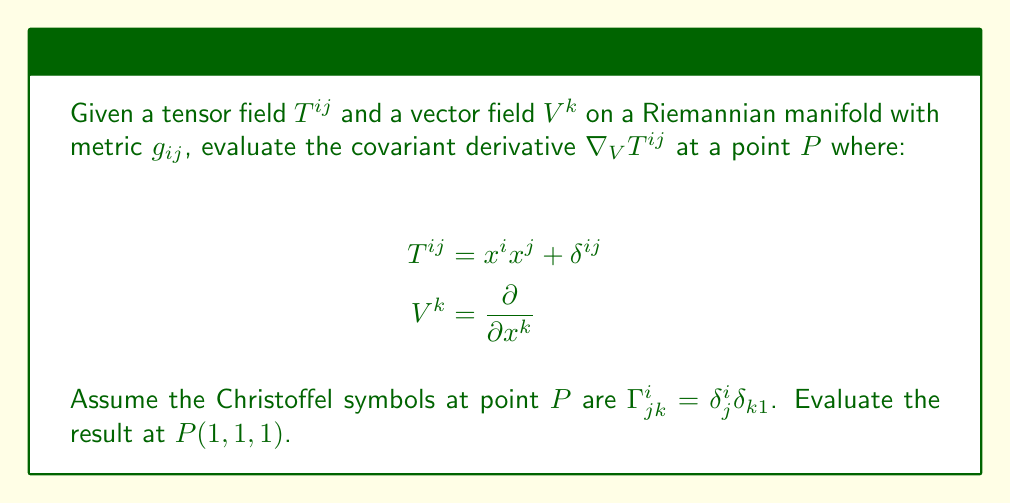Can you solve this math problem? To evaluate the covariant derivative of $T^{ij}$ along $V^k$, we use the formula:

$$\nabla_V T^{ij} = V^k \nabla_k T^{ij} = V^k (\partial_k T^{ij} + \Gamma^i_{kl} T^{lj} + \Gamma^j_{kl} T^{il})$$

Step 1: Calculate $\partial_k T^{ij}$
$$\partial_k T^{ij} = \partial_k (x^i x^j + \delta^{ij}) = \delta^i_k x^j + \delta^j_k x^i$$

Step 2: Evaluate $\Gamma^i_{kl} T^{lj}$
$$\Gamma^i_{kl} T^{lj} = \delta^i_k \delta_{l1} (x^l x^j + \delta^{lj}) = \delta^i_k \delta_{11} (x^1 x^j + \delta^{1j})$$

Step 3: Evaluate $\Gamma^j_{kl} T^{il}$
$$\Gamma^j_{kl} T^{il} = \delta^j_k \delta_{l1} (x^i x^l + \delta^{il}) = \delta^j_k \delta_{11} (x^i x^1 + \delta^{i1})$$

Step 4: Combine terms and simplify
$$\nabla_V T^{ij} = V^k (\delta^i_k x^j + \delta^j_k x^i + \delta^i_k \delta_{11} (x^1 x^j + \delta^{1j}) + \delta^j_k \delta_{11} (x^i x^1 + \delta^{i1}))$$

Step 5: Substitute $V^k = \frac{\partial}{\partial x^k}$ and evaluate at $P(1,1,1)$
$$\nabla_V T^{ij}|_P = x^j + x^i + \delta_{11} (x^1 x^j + \delta^{1j}) + \delta_{11} (x^i x^1 + \delta^{i1})$$
$$= 1 + 1 + (1 \cdot 1 + \delta^{1j}) + (1 \cdot 1 + \delta^{i1})$$
$$= 2 + 1 + \delta^{1j} + 1 + \delta^{i1}$$
$$= 4 + \delta^{1j} + \delta^{i1}$$
Answer: $\nabla_V T^{ij}|_P = 4 + \delta^{1j} + \delta^{i1}$ 